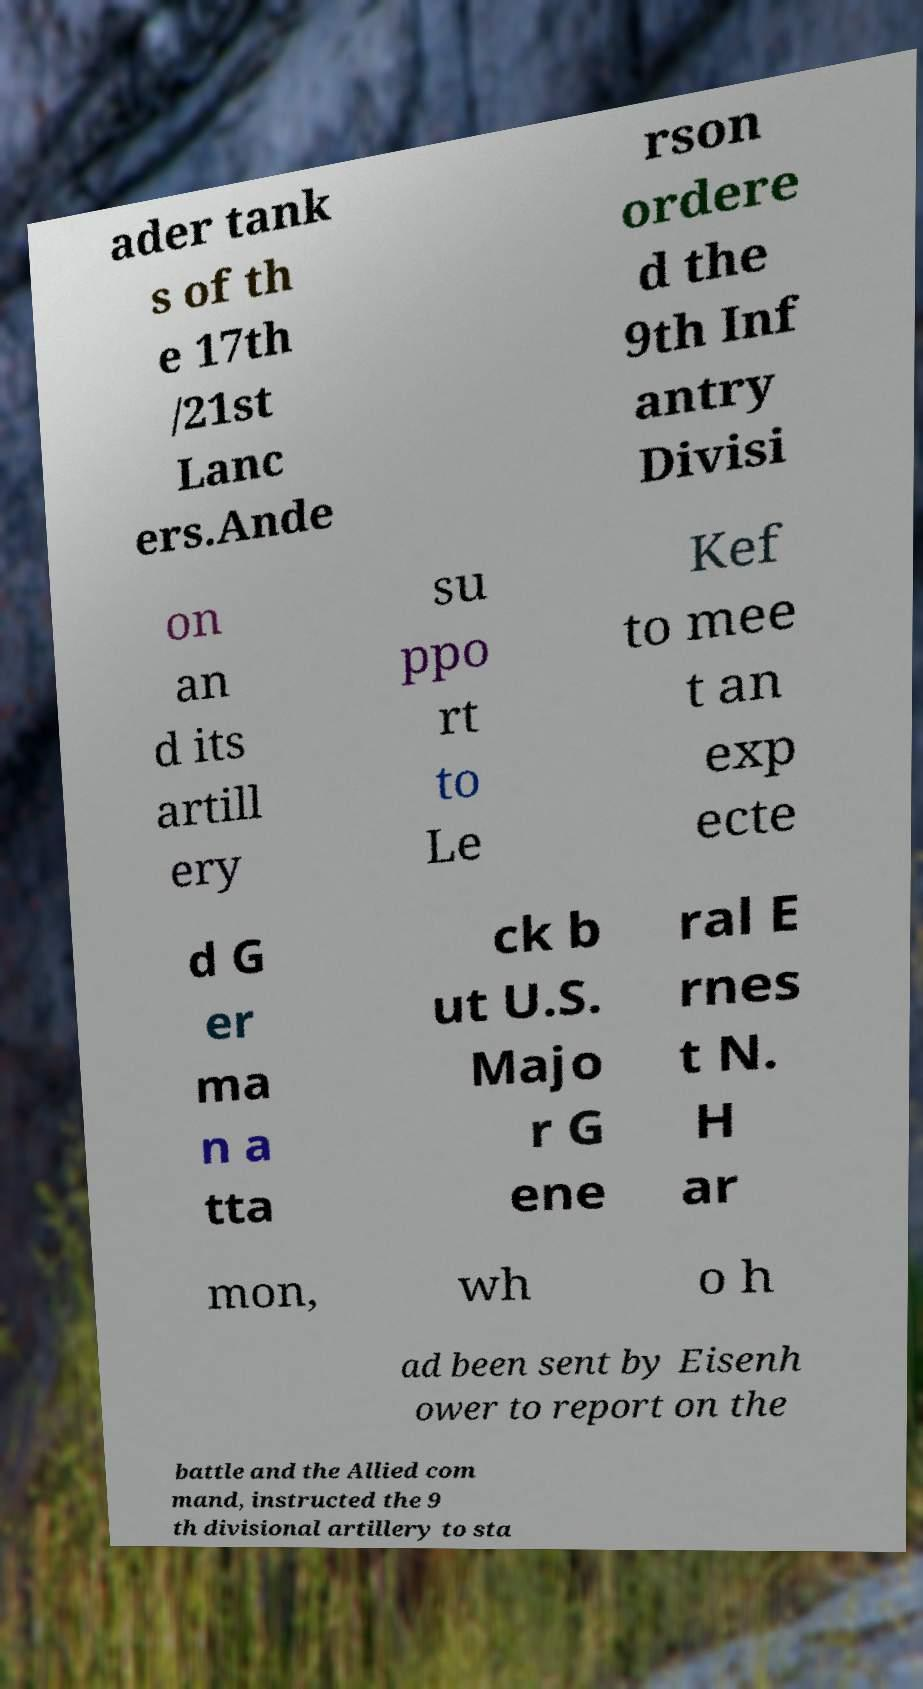Could you extract and type out the text from this image? ader tank s of th e 17th /21st Lanc ers.Ande rson ordere d the 9th Inf antry Divisi on an d its artill ery su ppo rt to Le Kef to mee t an exp ecte d G er ma n a tta ck b ut U.S. Majo r G ene ral E rnes t N. H ar mon, wh o h ad been sent by Eisenh ower to report on the battle and the Allied com mand, instructed the 9 th divisional artillery to sta 